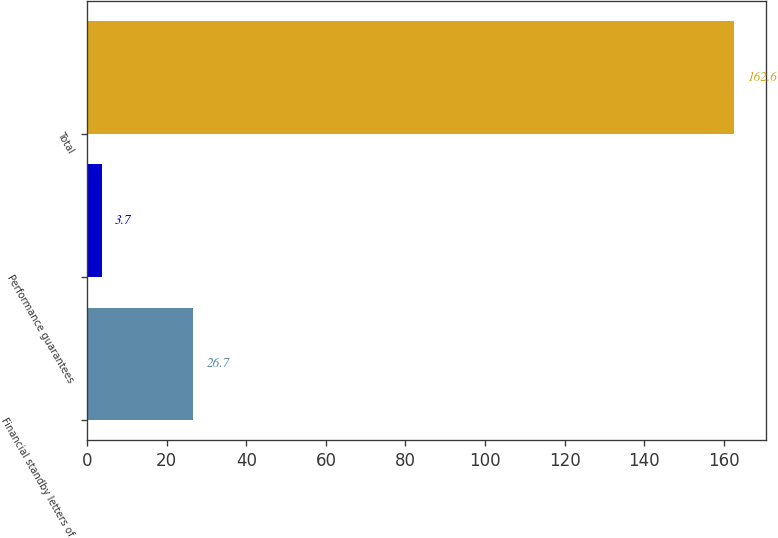Convert chart. <chart><loc_0><loc_0><loc_500><loc_500><bar_chart><fcel>Financial standby letters of<fcel>Performance guarantees<fcel>Total<nl><fcel>26.7<fcel>3.7<fcel>162.6<nl></chart> 